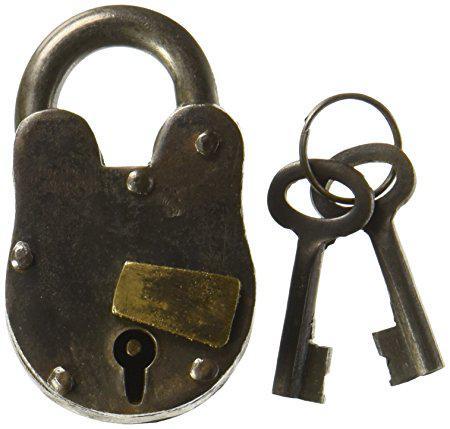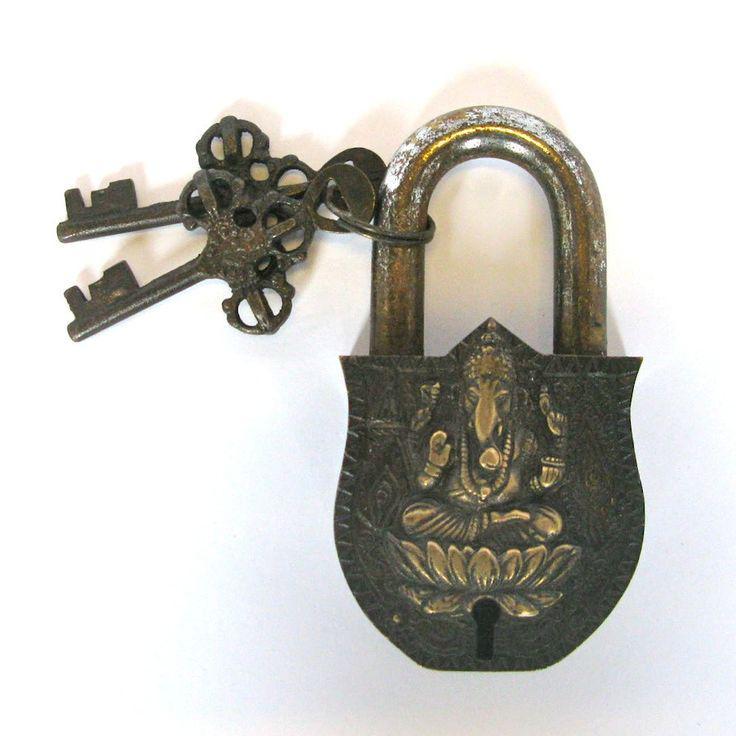The first image is the image on the left, the second image is the image on the right. Assess this claim about the two images: "In one of the images there is a lock with an image carved on the front and two keys attached to it.". Correct or not? Answer yes or no. Yes. The first image is the image on the left, the second image is the image on the right. Assess this claim about the two images: "An image shows a lock decorated with a human-like figure on its front and with a keyring attached.". Correct or not? Answer yes or no. Yes. 